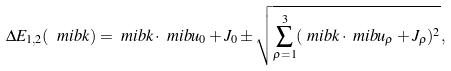<formula> <loc_0><loc_0><loc_500><loc_500>\Delta E _ { 1 , 2 } ( \ m i b { k } ) & = \ m i b { k } \cdot \ m i b { u } _ { 0 } + J _ { 0 } \pm \sqrt { \sum ^ { 3 } _ { \rho = 1 } ( \ m i b { k } \cdot \ m i b { u } _ { \rho } + J _ { \rho } ) ^ { 2 } } ,</formula> 